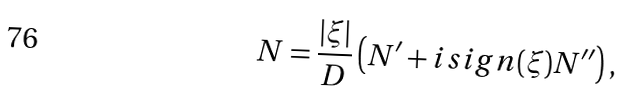<formula> <loc_0><loc_0><loc_500><loc_500>N = \frac { | \xi | } { D } \left ( N ^ { \prime } + i s i g n ( \xi ) N ^ { \prime \prime } \right ) ,</formula> 